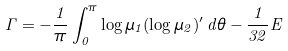<formula> <loc_0><loc_0><loc_500><loc_500>\Gamma = - \frac { 1 } { \pi } \int _ { 0 } ^ { \pi } \log \mu _ { 1 } ( \log \mu _ { 2 } ) ^ { \prime } \, d \theta - \frac { 1 } { 3 2 } E</formula> 